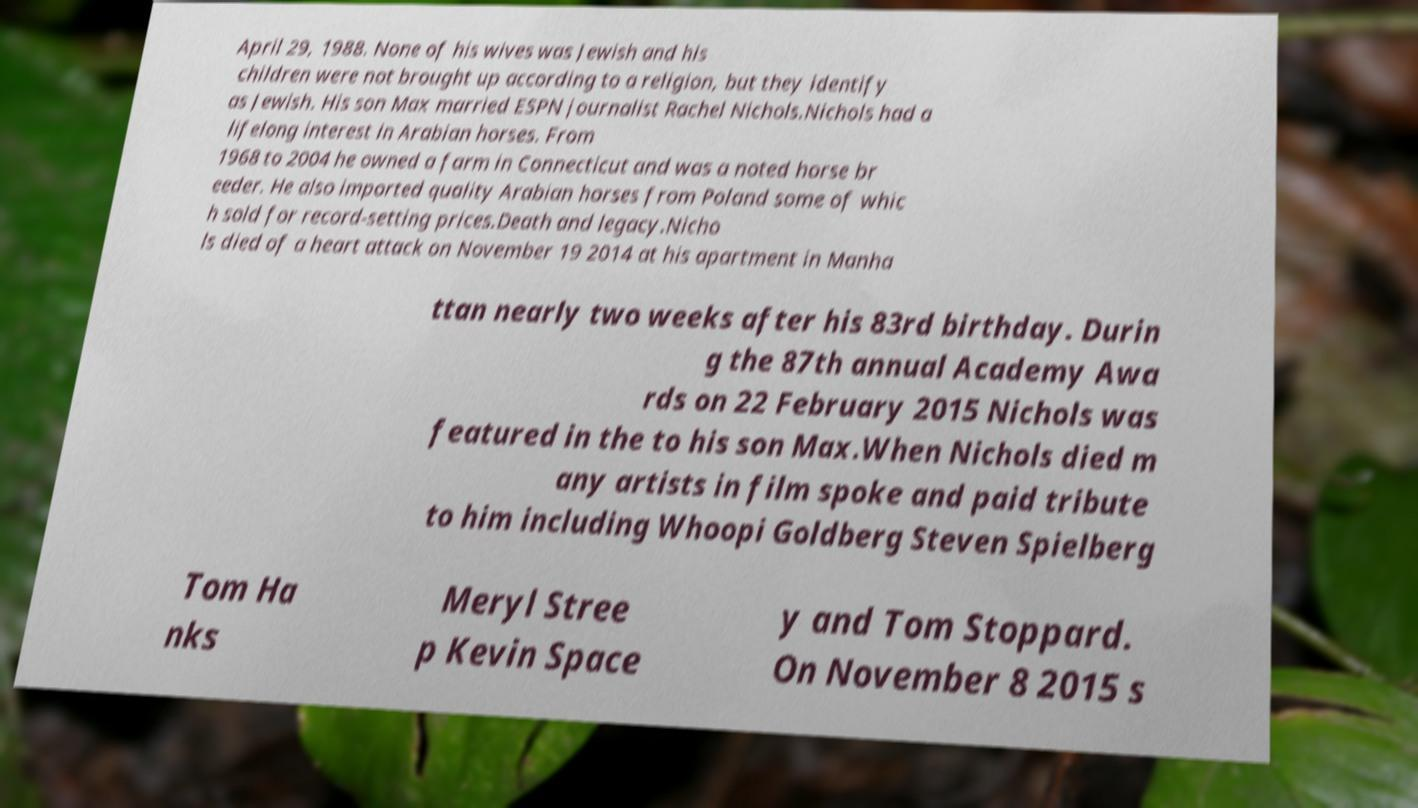Can you accurately transcribe the text from the provided image for me? April 29, 1988. None of his wives was Jewish and his children were not brought up according to a religion, but they identify as Jewish. His son Max married ESPN journalist Rachel Nichols.Nichols had a lifelong interest in Arabian horses. From 1968 to 2004 he owned a farm in Connecticut and was a noted horse br eeder. He also imported quality Arabian horses from Poland some of whic h sold for record-setting prices.Death and legacy.Nicho ls died of a heart attack on November 19 2014 at his apartment in Manha ttan nearly two weeks after his 83rd birthday. Durin g the 87th annual Academy Awa rds on 22 February 2015 Nichols was featured in the to his son Max.When Nichols died m any artists in film spoke and paid tribute to him including Whoopi Goldberg Steven Spielberg Tom Ha nks Meryl Stree p Kevin Space y and Tom Stoppard. On November 8 2015 s 